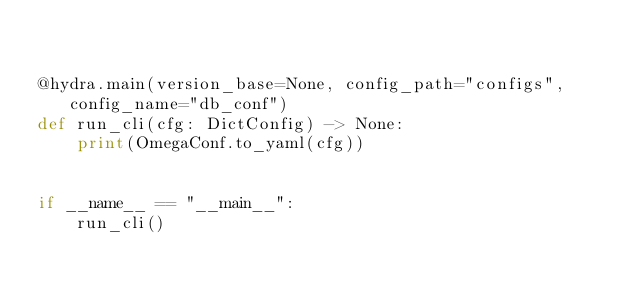Convert code to text. <code><loc_0><loc_0><loc_500><loc_500><_Python_>

@hydra.main(version_base=None, config_path="configs", config_name="db_conf")
def run_cli(cfg: DictConfig) -> None:
    print(OmegaConf.to_yaml(cfg))


if __name__ == "__main__":
    run_cli()
</code> 